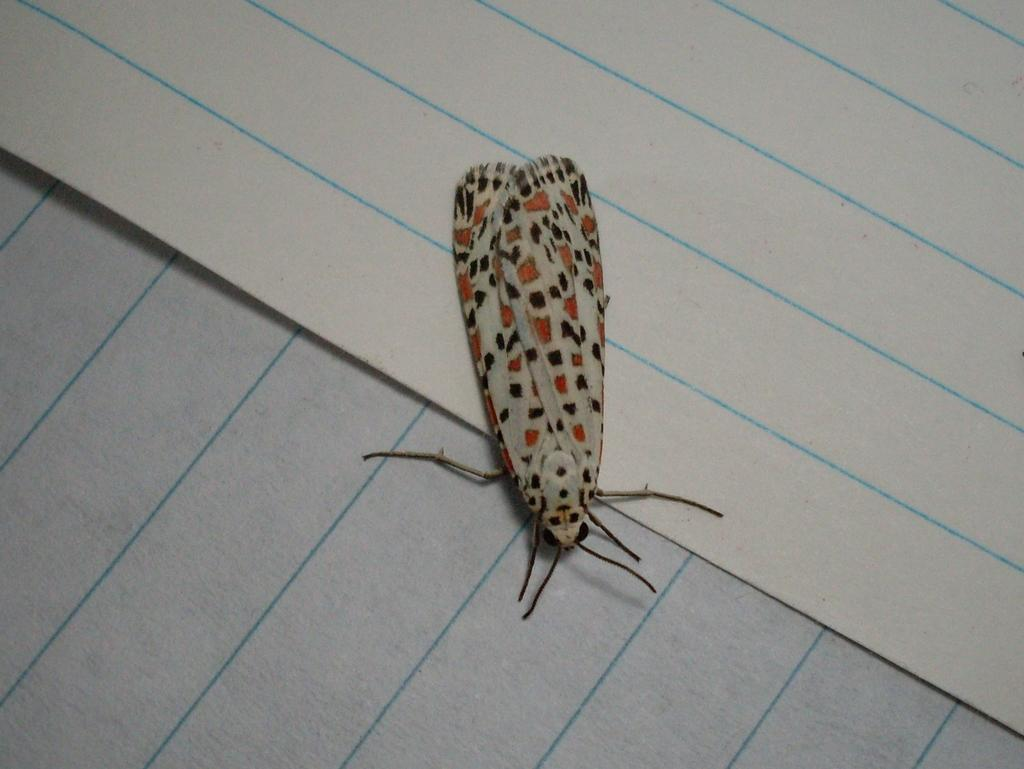What objects are present on the papers in the image? There is a fly on the papers in the image. How many papers can be seen in the image? There are two papers in the image. What type of steel is used to create the distribution of water in the image? There is no steel, distribution, or water present in the image; it only features two papers with a fly on them. 